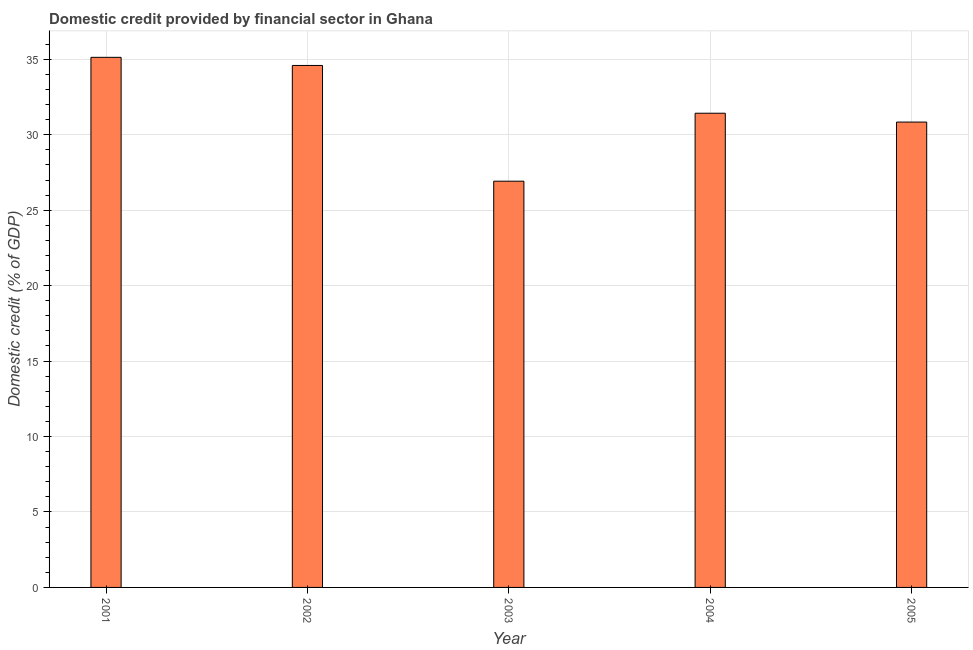Does the graph contain grids?
Your answer should be compact. Yes. What is the title of the graph?
Offer a terse response. Domestic credit provided by financial sector in Ghana. What is the label or title of the Y-axis?
Your response must be concise. Domestic credit (% of GDP). What is the domestic credit provided by financial sector in 2001?
Offer a terse response. 35.13. Across all years, what is the maximum domestic credit provided by financial sector?
Give a very brief answer. 35.13. Across all years, what is the minimum domestic credit provided by financial sector?
Ensure brevity in your answer.  26.92. In which year was the domestic credit provided by financial sector maximum?
Your answer should be compact. 2001. In which year was the domestic credit provided by financial sector minimum?
Keep it short and to the point. 2003. What is the sum of the domestic credit provided by financial sector?
Your answer should be compact. 158.91. What is the difference between the domestic credit provided by financial sector in 2002 and 2003?
Offer a terse response. 7.67. What is the average domestic credit provided by financial sector per year?
Provide a succinct answer. 31.78. What is the median domestic credit provided by financial sector?
Provide a short and direct response. 31.43. Do a majority of the years between 2003 and 2001 (inclusive) have domestic credit provided by financial sector greater than 31 %?
Offer a terse response. Yes. What is the ratio of the domestic credit provided by financial sector in 2001 to that in 2004?
Make the answer very short. 1.12. What is the difference between the highest and the second highest domestic credit provided by financial sector?
Your answer should be compact. 0.54. What is the difference between the highest and the lowest domestic credit provided by financial sector?
Provide a succinct answer. 8.21. Are all the bars in the graph horizontal?
Give a very brief answer. No. What is the difference between two consecutive major ticks on the Y-axis?
Ensure brevity in your answer.  5. Are the values on the major ticks of Y-axis written in scientific E-notation?
Your response must be concise. No. What is the Domestic credit (% of GDP) of 2001?
Offer a very short reply. 35.13. What is the Domestic credit (% of GDP) of 2002?
Make the answer very short. 34.59. What is the Domestic credit (% of GDP) of 2003?
Your answer should be very brief. 26.92. What is the Domestic credit (% of GDP) in 2004?
Provide a short and direct response. 31.43. What is the Domestic credit (% of GDP) in 2005?
Offer a terse response. 30.84. What is the difference between the Domestic credit (% of GDP) in 2001 and 2002?
Keep it short and to the point. 0.54. What is the difference between the Domestic credit (% of GDP) in 2001 and 2003?
Ensure brevity in your answer.  8.21. What is the difference between the Domestic credit (% of GDP) in 2001 and 2004?
Keep it short and to the point. 3.7. What is the difference between the Domestic credit (% of GDP) in 2001 and 2005?
Offer a terse response. 4.29. What is the difference between the Domestic credit (% of GDP) in 2002 and 2003?
Give a very brief answer. 7.67. What is the difference between the Domestic credit (% of GDP) in 2002 and 2004?
Keep it short and to the point. 3.17. What is the difference between the Domestic credit (% of GDP) in 2002 and 2005?
Ensure brevity in your answer.  3.75. What is the difference between the Domestic credit (% of GDP) in 2003 and 2004?
Offer a very short reply. -4.5. What is the difference between the Domestic credit (% of GDP) in 2003 and 2005?
Offer a terse response. -3.92. What is the difference between the Domestic credit (% of GDP) in 2004 and 2005?
Provide a succinct answer. 0.59. What is the ratio of the Domestic credit (% of GDP) in 2001 to that in 2002?
Your answer should be compact. 1.02. What is the ratio of the Domestic credit (% of GDP) in 2001 to that in 2003?
Your response must be concise. 1.3. What is the ratio of the Domestic credit (% of GDP) in 2001 to that in 2004?
Make the answer very short. 1.12. What is the ratio of the Domestic credit (% of GDP) in 2001 to that in 2005?
Offer a terse response. 1.14. What is the ratio of the Domestic credit (% of GDP) in 2002 to that in 2003?
Your response must be concise. 1.28. What is the ratio of the Domestic credit (% of GDP) in 2002 to that in 2004?
Offer a terse response. 1.1. What is the ratio of the Domestic credit (% of GDP) in 2002 to that in 2005?
Your answer should be compact. 1.12. What is the ratio of the Domestic credit (% of GDP) in 2003 to that in 2004?
Your answer should be compact. 0.86. What is the ratio of the Domestic credit (% of GDP) in 2003 to that in 2005?
Your answer should be very brief. 0.87. 